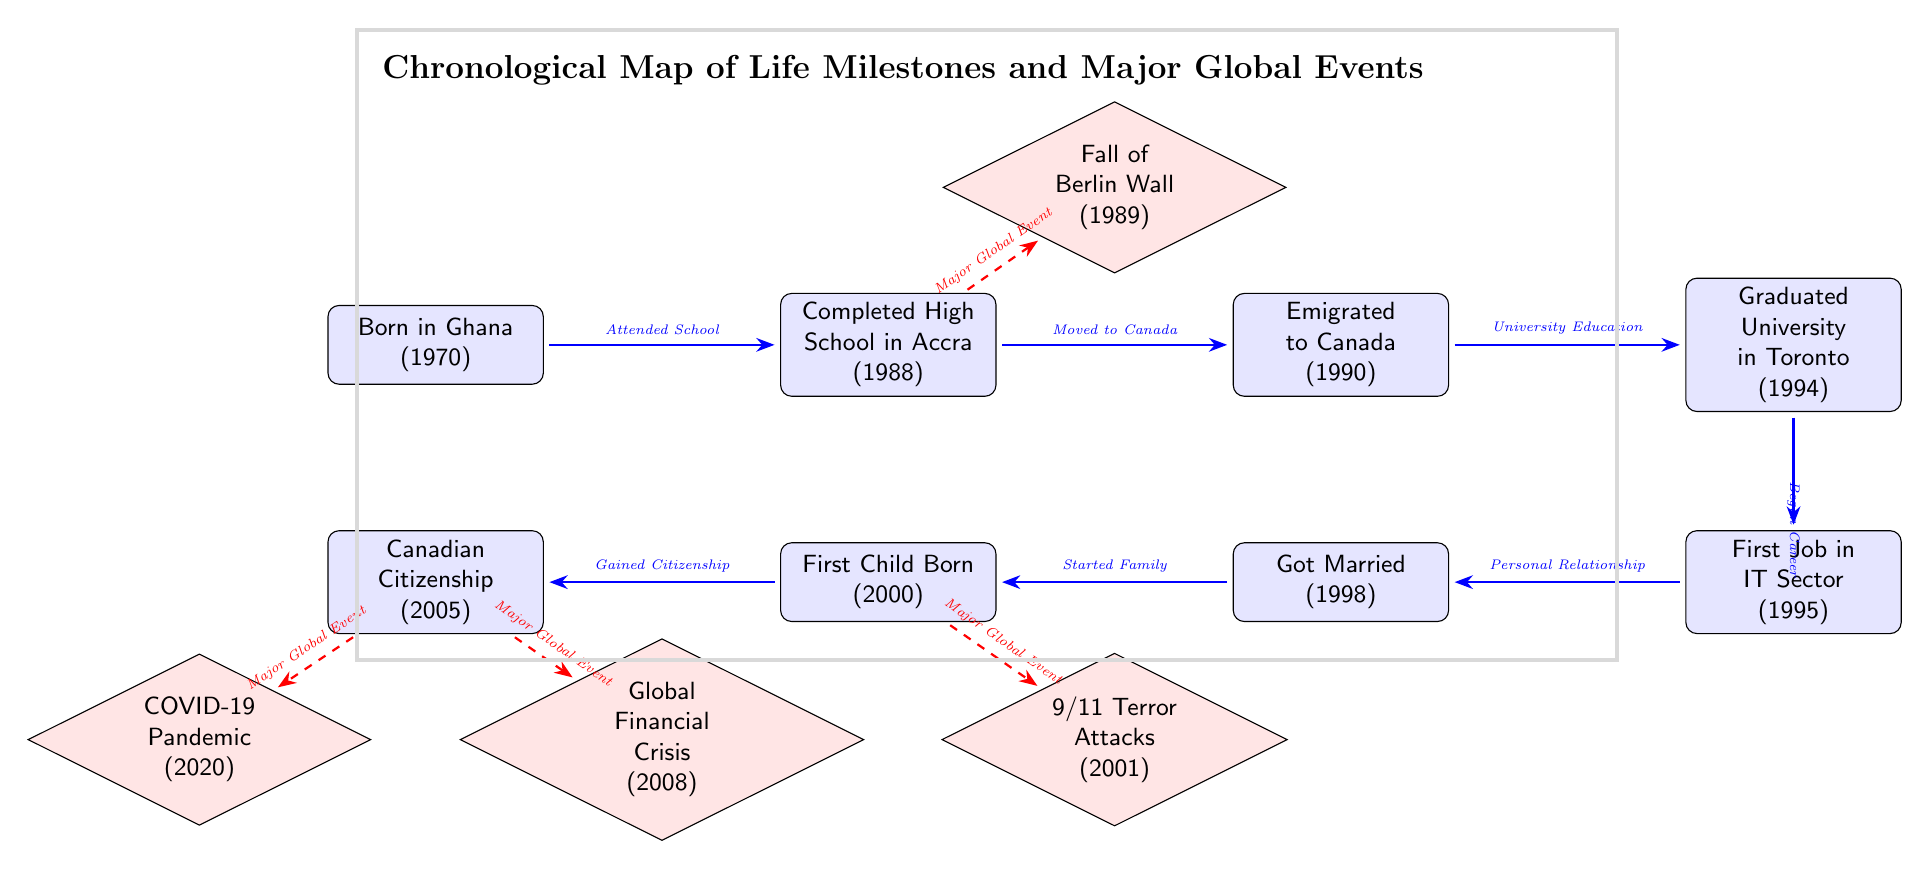What year did the first child born event occur? The diagram shows the event "First Child Born" is located at 2000. This is directly stated in the event node.
Answer: 2000 What was the immediate event after gaining Canadian citizenship? The diagram indicates that after the "Canadian Citizenship" event, the next event is "COVID-19 Pandemic," which is shown as a global event linked by a dashed arrow.
Answer: COVID-19 Pandemic How many global events are depicted in the diagram? The diagram features four global events: the Fall of Berlin Wall, 9/11 Terror Attacks, Global Financial Crisis, and COVID-19 Pandemic. By counting the global event nodes, we confirm this total.
Answer: 4 What major life milestone occurs immediately after getting married? According to the diagram, "First Child Born" is the immediate event following "Got Married," as indicated by the blue arrow connecting these two events.
Answer: First Child Born What major global event is linked to the year 2001? The diagram shows a dashed arrow from the "First Child Born" event to the "9/11 Terror Attacks" global event, indicating a direct relationship in the timeline. Hence, 2001 corresponds to the 9/11 Terror Attacks.
Answer: 9/11 Terror Attacks What role does the "University Education" node play in the personal timeline? The "University Education" node is a crucial step in the personal timeline, serving as the immediate precursor to "First Job in IT Sector." It shows the individual's progression from education to employment.
Answer: Step in progress What is the color used for the global events in the diagram? The global events are represented in red, as indicated by the filling style of the nodes for global events throughout the diagram.
Answer: Red Which event necessitated moving from Ghana to Canada? The diagram indicates that "Emigrated to Canada" follows directly after "Completed High School in Accra," suggesting this transition was a next step after high school.
Answer: Completed High School in Accra How is the relationship between “Gained Citizenship” and “Global Financial Crisis”? The diagram shows a dashed arrow from the "Gained Citizenship" event to the "Global Financial Crisis," indicating that the financial crisis is a significant global event that occurred during this period.
Answer: Major Global Event 